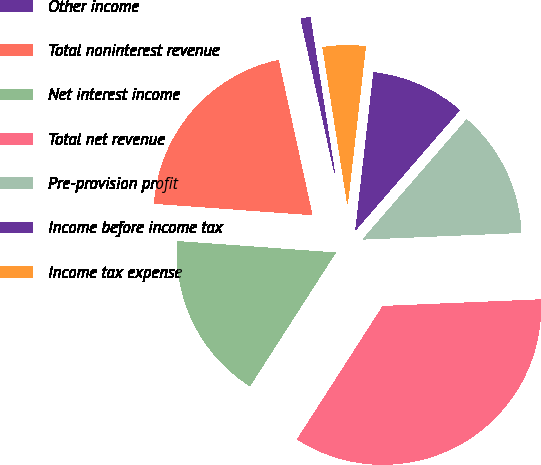Convert chart to OTSL. <chart><loc_0><loc_0><loc_500><loc_500><pie_chart><fcel>Other income<fcel>Total noninterest revenue<fcel>Net interest income<fcel>Total net revenue<fcel>Pre-provision profit<fcel>Income before income tax<fcel>Income tax expense<nl><fcel>0.93%<fcel>20.43%<fcel>17.05%<fcel>34.76%<fcel>12.95%<fcel>9.56%<fcel>4.31%<nl></chart> 